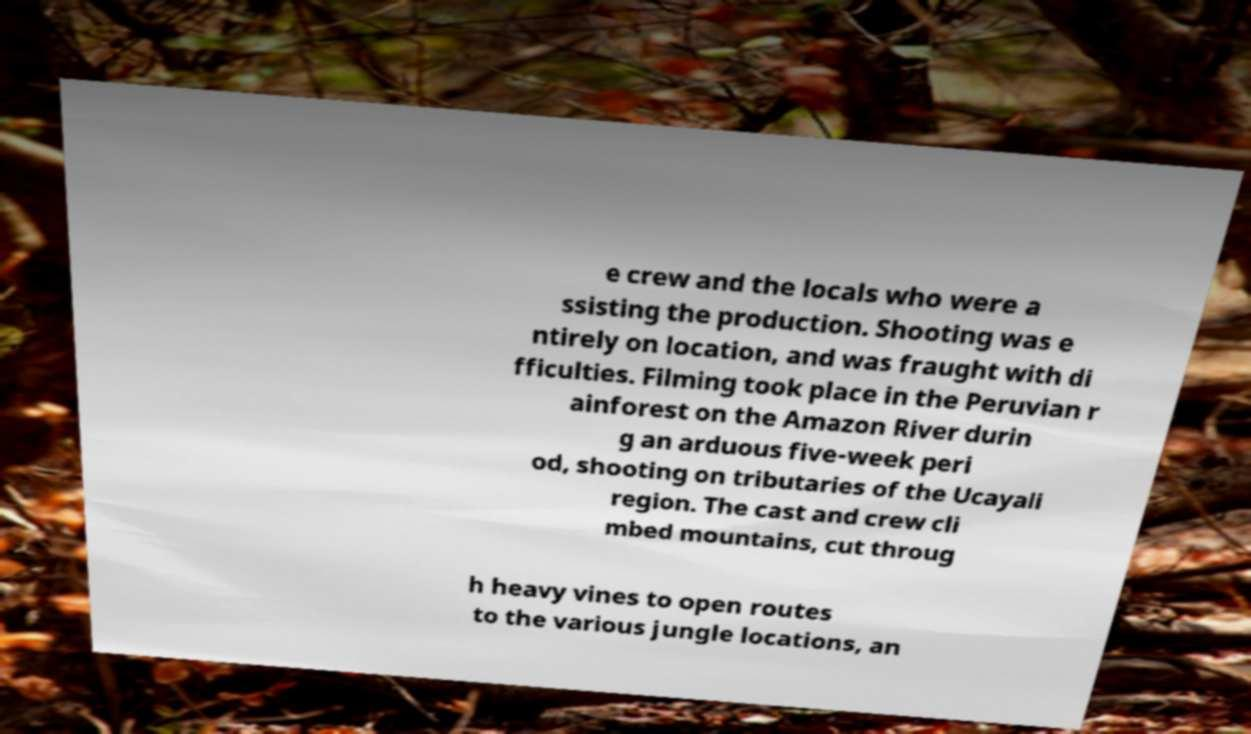There's text embedded in this image that I need extracted. Can you transcribe it verbatim? e crew and the locals who were a ssisting the production. Shooting was e ntirely on location, and was fraught with di fficulties. Filming took place in the Peruvian r ainforest on the Amazon River durin g an arduous five-week peri od, shooting on tributaries of the Ucayali region. The cast and crew cli mbed mountains, cut throug h heavy vines to open routes to the various jungle locations, an 